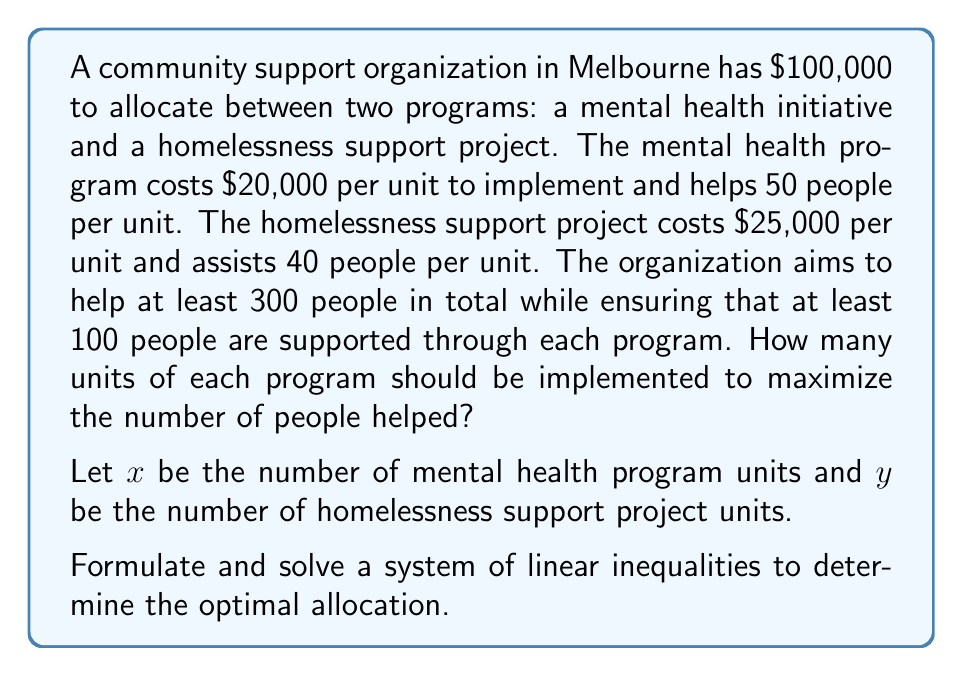Help me with this question. Let's approach this step-by-step:

1) First, we need to set up our constraints:

   a) Budget constraint: $20000x + 25000y \leq 100000$
   b) Total people helped: $50x + 40y \geq 300$
   c) Minimum people helped by mental health program: $50x \geq 100$
   d) Minimum people helped by homelessness project: $40y \geq 100$
   e) Non-negativity: $x \geq 0, y \geq 0$

2) Simplify the constraints:
   a) $4x + 5y \leq 20$
   b) $5x + 4y \geq 30$
   c) $x \geq 2$
   d) $y \geq 2.5$

3) Plot these inequalities on a graph. The feasible region will be the area that satisfies all constraints.

4) The objective is to maximize $50x + 40y$, which represents the total number of people helped.

5) To find the optimal solution, we need to evaluate the objective function at each corner point of the feasible region.

6) The corner points are:
   (2, 2.5), (2, 3.2), (3.6, 2.5), (4, 2)

7) Evaluating the objective function at each point:
   (2, 2.5): $50(2) + 40(2.5) = 200$
   (2, 3.2): $50(2) + 40(3.2) = 228$
   (3.6, 2.5): $50(3.6) + 40(2.5) = 280$
   (4, 2): $50(4) + 40(2) = 280$

8) The maximum value is 280, which occurs at two points: (3.6, 2.5) and (4, 2).

9) Since we need integer solutions, we round down to (3, 2) or (4, 2).

10) Checking these points:
    (3, 2): 3 units of mental health program and 2 units of homelessness project
            Helps $50(3) + 40(2) = 230$ people
            Costs $20000(3) + 25000(2) = 110000$ (exceeds budget)
    
    (4, 2): 4 units of mental health program and 2 units of homelessness project
            Helps $50(4) + 40(2) = 280$ people
            Costs $20000(4) + 25000(2) = 130000$ (exceeds budget)

11) We need to adjust to fit the budget. The next best integer solution is (3, 2):
    (3, 2): 3 units of mental health program and 2 units of homelessness project
            Helps $50(3) + 40(2) = 230$ people
            Costs $20000(3) + 25000(2) = 110000$ (exceeds budget)

12) To fit the budget, we can implement 3 units of mental health program and 1 unit of homelessness project:
    (3, 1): Helps $50(3) + 40(1) = 190$ people
            Costs $20000(3) + 25000(1) = 85000$ (within budget)
Answer: 3 units of mental health program, 1 unit of homelessness project 